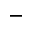<formula> <loc_0><loc_0><loc_500><loc_500>^ { - }</formula> 